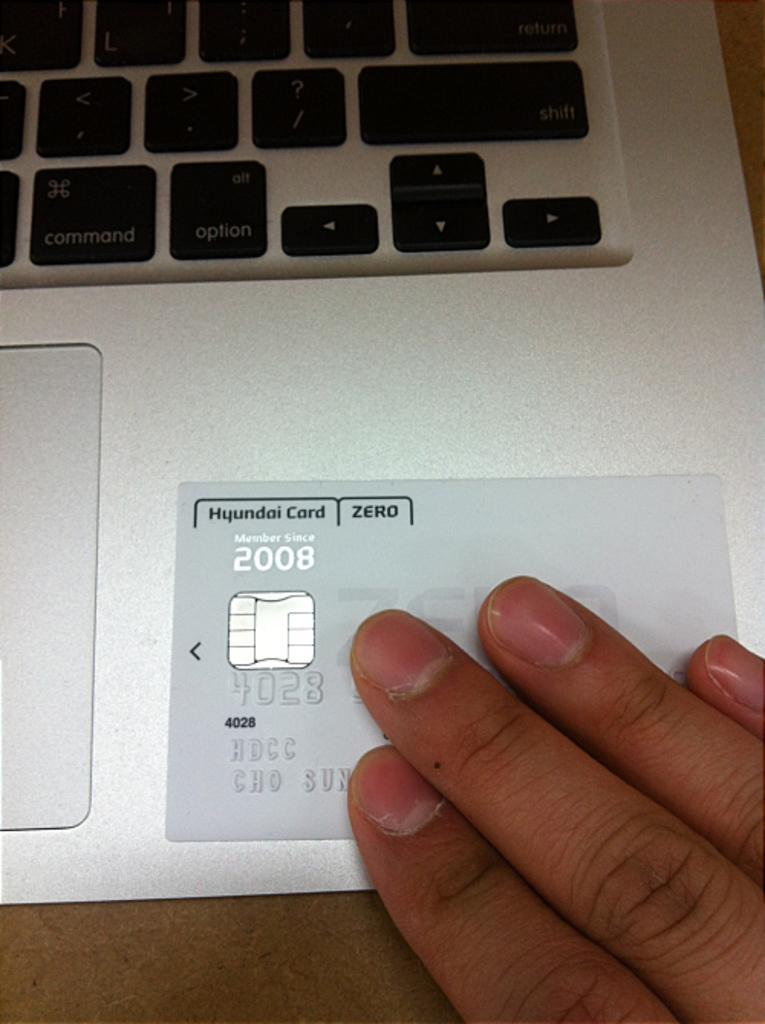Provide a one-sentence caption for the provided image. A person holding a Hyundai credit card on a laptop. 